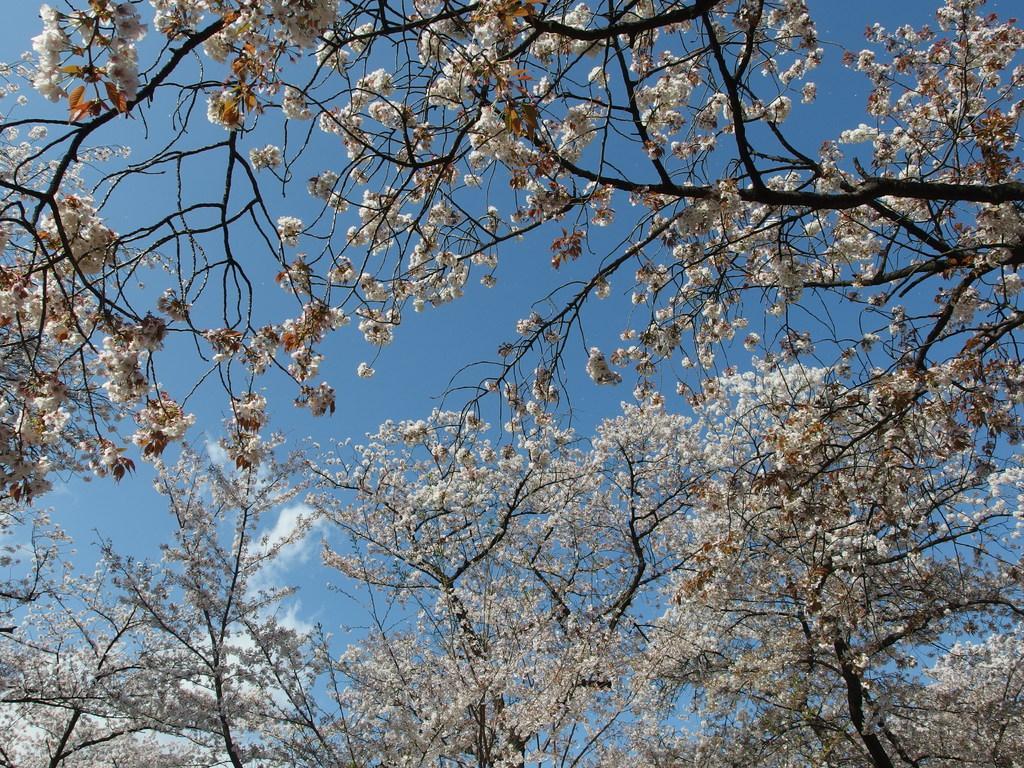Please provide a concise description of this image. In this picture there are trees and there are white color flowers on the trees. At the top there is sky and there are clouds. 